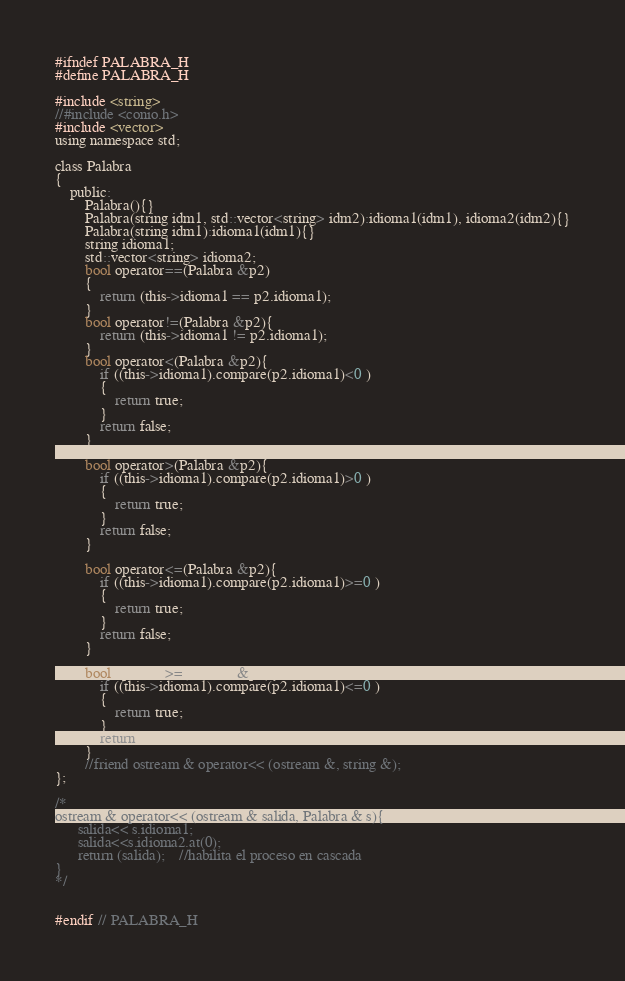<code> <loc_0><loc_0><loc_500><loc_500><_C_>#ifndef PALABRA_H
#define PALABRA_H

#include <string>
//#include <conio.h>
#include <vector>
using namespace std;

class Palabra
{
    public:
        Palabra(){}
        Palabra(string idm1, std::vector<string> idm2):idioma1(idm1), idioma2(idm2){}
        Palabra(string idm1):idioma1(idm1){}
        string idioma1;
        std::vector<string> idioma2;
        bool operator==(Palabra &p2)
        {
            return (this->idioma1 == p2.idioma1);
        }
        bool operator!=(Palabra &p2){
            return (this->idioma1 != p2.idioma1);
        }
        bool operator<(Palabra &p2){
            if ((this->idioma1).compare(p2.idioma1)<0 )
            {
                return true;
            }
            return false;
        }

        bool operator>(Palabra &p2){
            if ((this->idioma1).compare(p2.idioma1)>0 )
            {
                return true;
            }
            return false;
        }

        bool operator<=(Palabra &p2){
            if ((this->idioma1).compare(p2.idioma1)>=0 )
            {
                return true;
            }
            return false;
        }

        bool operator>=(Palabra &p2){
            if ((this->idioma1).compare(p2.idioma1)<=0 )
            {
                return true;
            }
            return false;
        }
        //friend ostream & operator<< (ostream &, string &);
};

/*
ostream & operator<< (ostream & salida, Palabra & s){
      salida<< s.idioma1;
      salida<<s.idioma2.at(0);
      return (salida);    //habilita el proceso en cascada
}
*/


#endif // PALABRA_H
</code> 